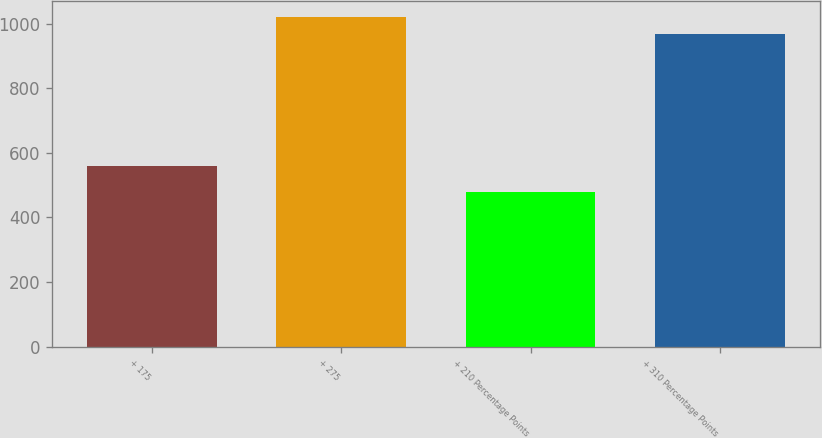Convert chart. <chart><loc_0><loc_0><loc_500><loc_500><bar_chart><fcel>+ 175<fcel>+ 275<fcel>+ 210 Percentage Points<fcel>+ 310 Percentage Points<nl><fcel>558<fcel>1019.9<fcel>478<fcel>967<nl></chart> 